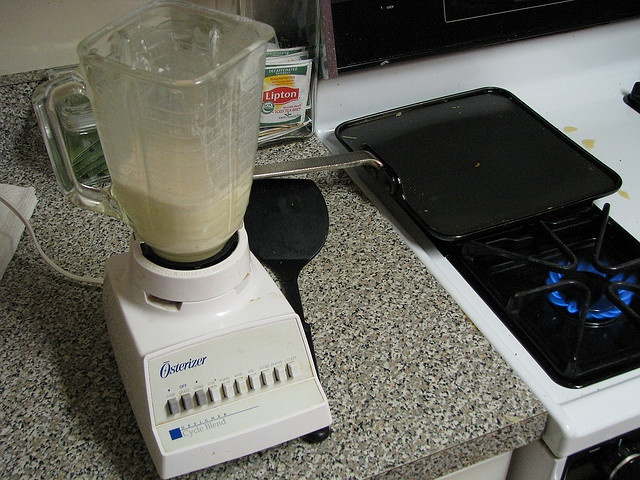Describe the objects in this image and their specific colors. I can see oven in gray, black, lightgray, and darkgray tones and spoon in gray, black, and darkgray tones in this image. 